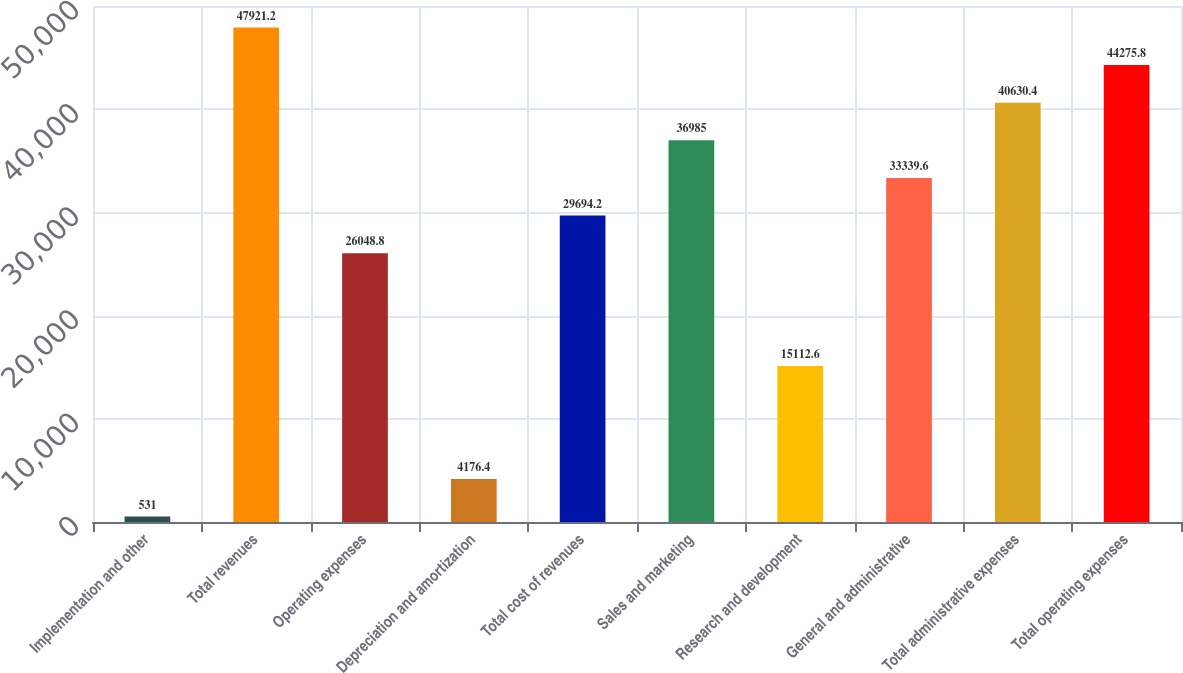<chart> <loc_0><loc_0><loc_500><loc_500><bar_chart><fcel>Implementation and other<fcel>Total revenues<fcel>Operating expenses<fcel>Depreciation and amortization<fcel>Total cost of revenues<fcel>Sales and marketing<fcel>Research and development<fcel>General and administrative<fcel>Total administrative expenses<fcel>Total operating expenses<nl><fcel>531<fcel>47921.2<fcel>26048.8<fcel>4176.4<fcel>29694.2<fcel>36985<fcel>15112.6<fcel>33339.6<fcel>40630.4<fcel>44275.8<nl></chart> 